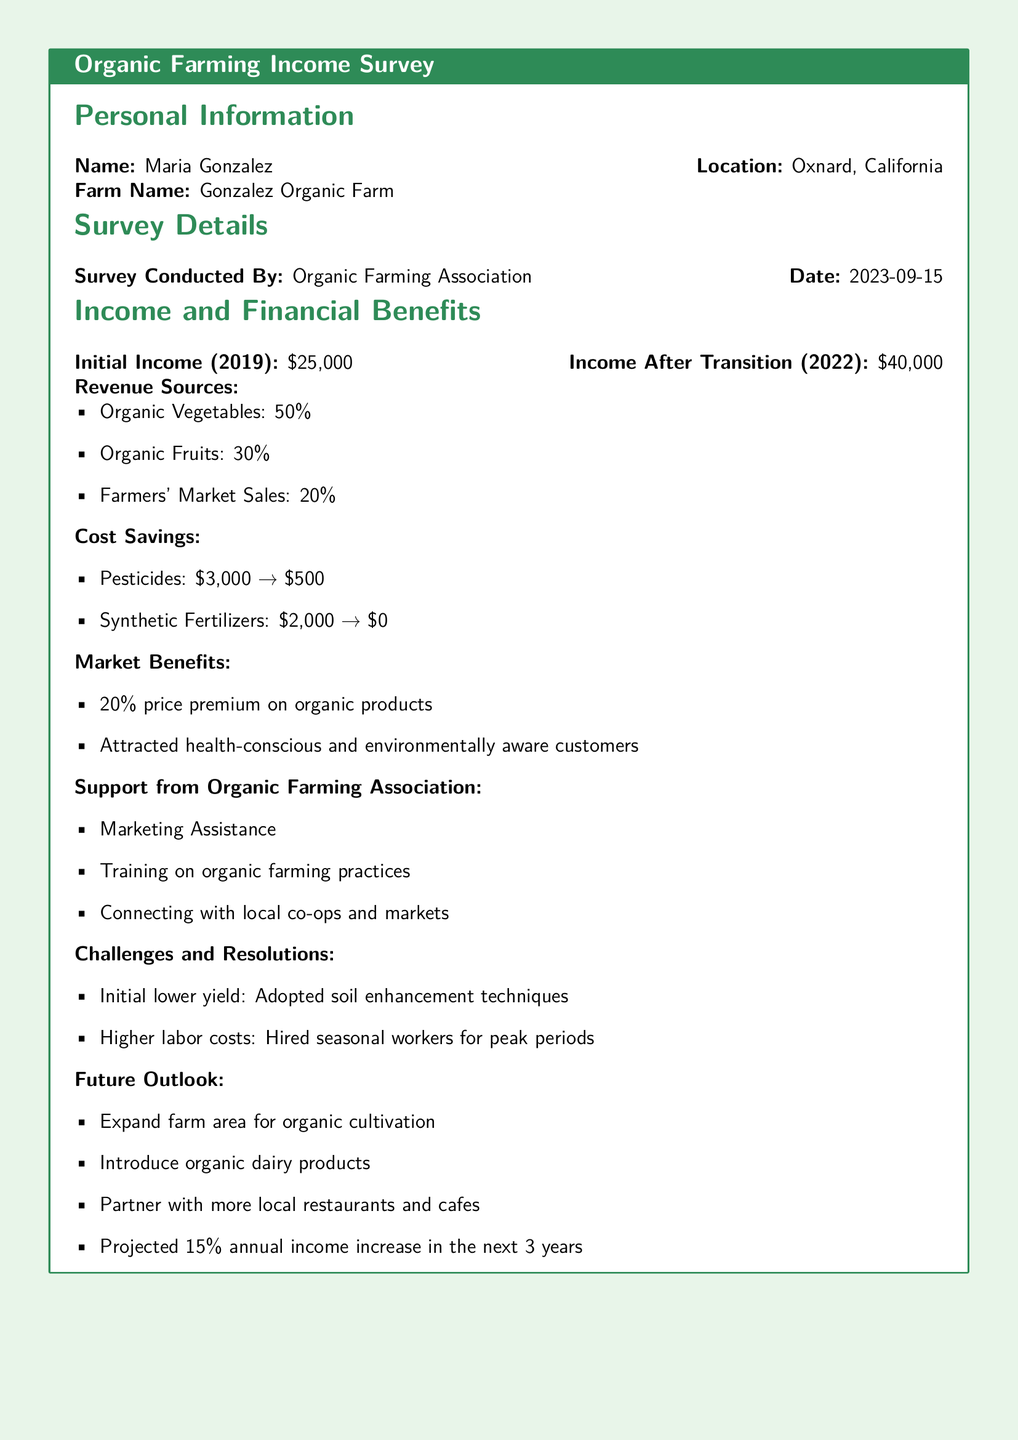What is the name of the farmer? The document provides the name of the farmer, which is listed at the top.
Answer: Maria Gonzalez What is the location of the farm? The location of the farm is specified in the personal information section of the document.
Answer: Oxnard, California What was the initial income in 2019? The document states the initial income clearly as mentioned in the income section.
Answer: $25,000 How much income did the farmer make after the transition in 2022? The survey details the income after transitioning to organic farming practices in the document.
Answer: $40,000 What percentage of revenue comes from organic vegetables? The revenue sources section outlines the percentage of revenue generated from organic vegetables.
Answer: 50% What was the cost of pesticides before and after the transition? The cost savings section provides details about the pesticide costs before and after transitioning to organic farming.
Answer: $3,000 → $500 What type of customers were attracted due to marketing? The document notes specific customer types attracted to the organic products due to marketing efforts.
Answer: Health-conscious and environmentally aware customers What assistance did the Organic Farming Association provide? The support from the Organic Farming Association section lists various types of assistance offered.
Answer: Marketing Assistance What is the projected annual income increase over the next three years? The future outlook section of the document mentions the projected income increase.
Answer: 15% 